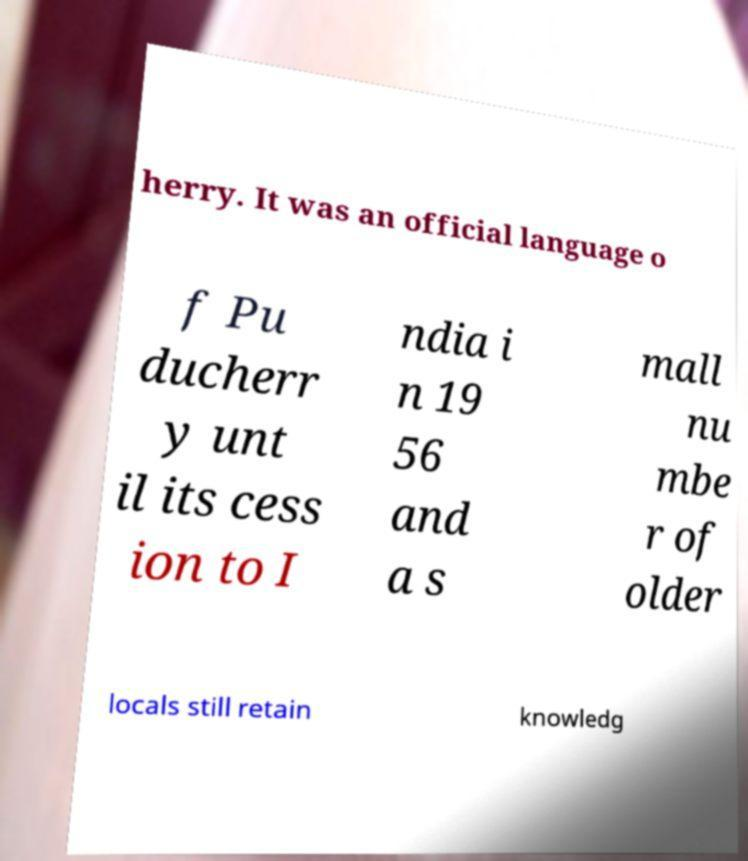Please identify and transcribe the text found in this image. herry. It was an official language o f Pu ducherr y unt il its cess ion to I ndia i n 19 56 and a s mall nu mbe r of older locals still retain knowledg 